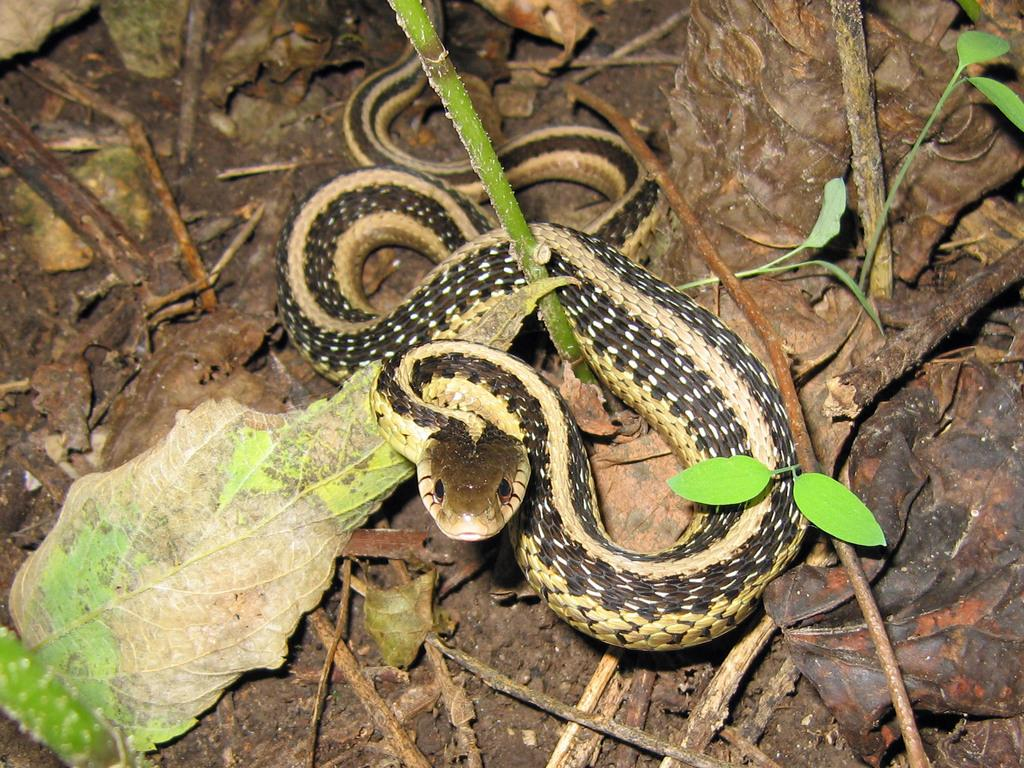What type of animal is present in the image? There is a snake in the image. What type of plant material can be seen in the image? There are leaves and stems in the image. What type of twig is the snake using as a perch in the image? There is no twig present in the image; the snake is not shown using any perch. What type of pump is visible in the image? There is no pump present in the image. 